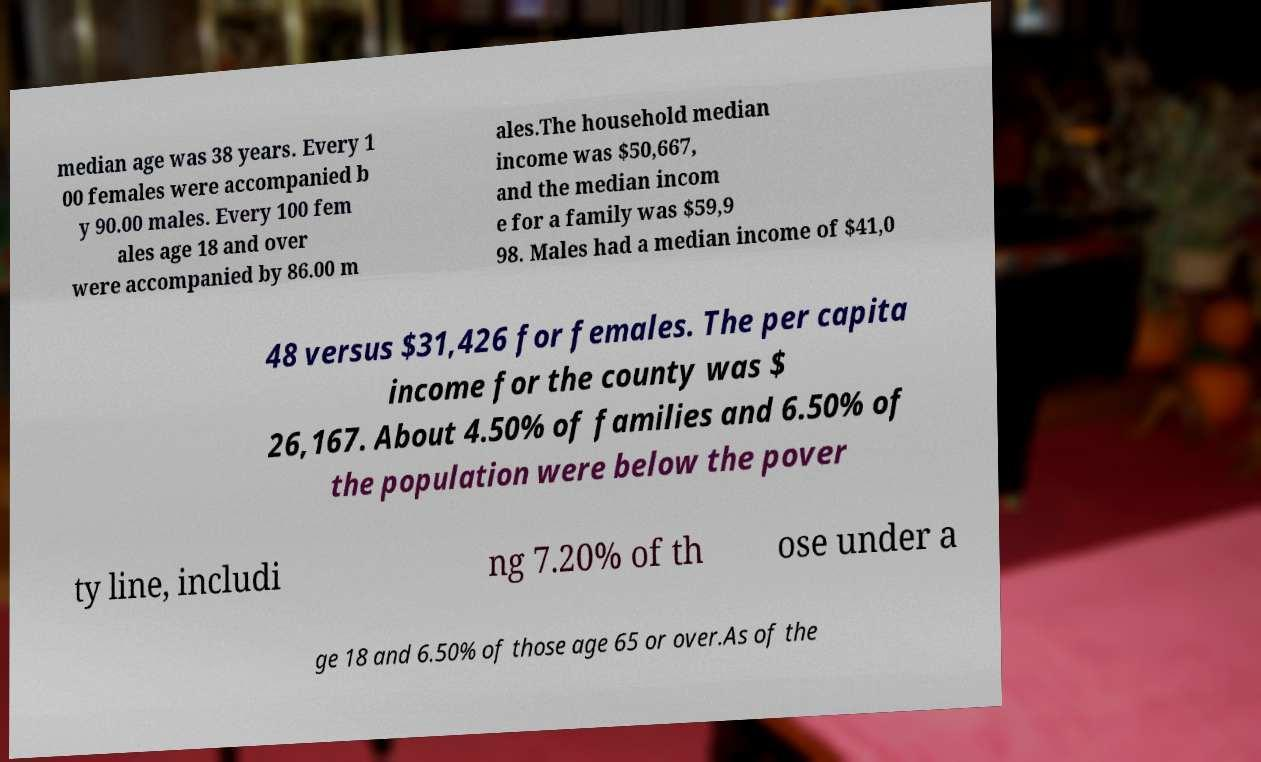Please read and relay the text visible in this image. What does it say? median age was 38 years. Every 1 00 females were accompanied b y 90.00 males. Every 100 fem ales age 18 and over were accompanied by 86.00 m ales.The household median income was $50,667, and the median incom e for a family was $59,9 98. Males had a median income of $41,0 48 versus $31,426 for females. The per capita income for the county was $ 26,167. About 4.50% of families and 6.50% of the population were below the pover ty line, includi ng 7.20% of th ose under a ge 18 and 6.50% of those age 65 or over.As of the 